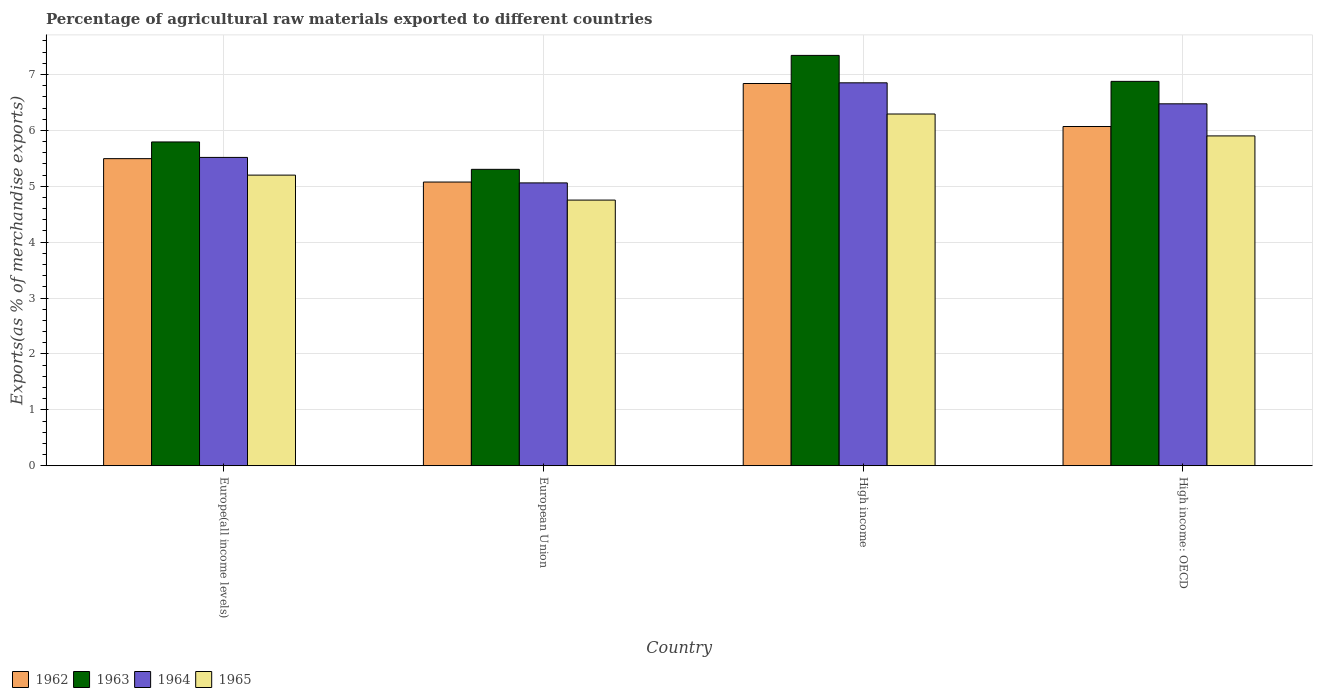How many bars are there on the 2nd tick from the left?
Offer a very short reply. 4. What is the percentage of exports to different countries in 1965 in High income?
Keep it short and to the point. 6.29. Across all countries, what is the maximum percentage of exports to different countries in 1965?
Keep it short and to the point. 6.29. Across all countries, what is the minimum percentage of exports to different countries in 1963?
Give a very brief answer. 5.3. What is the total percentage of exports to different countries in 1965 in the graph?
Your answer should be very brief. 22.14. What is the difference between the percentage of exports to different countries in 1963 in European Union and that in High income: OECD?
Keep it short and to the point. -1.57. What is the difference between the percentage of exports to different countries in 1963 in High income: OECD and the percentage of exports to different countries in 1964 in European Union?
Your answer should be compact. 1.82. What is the average percentage of exports to different countries in 1963 per country?
Your response must be concise. 6.33. What is the difference between the percentage of exports to different countries of/in 1962 and percentage of exports to different countries of/in 1963 in High income?
Offer a very short reply. -0.5. In how many countries, is the percentage of exports to different countries in 1964 greater than 0.2 %?
Offer a terse response. 4. What is the ratio of the percentage of exports to different countries in 1965 in Europe(all income levels) to that in European Union?
Offer a very short reply. 1.09. Is the difference between the percentage of exports to different countries in 1962 in Europe(all income levels) and High income greater than the difference between the percentage of exports to different countries in 1963 in Europe(all income levels) and High income?
Provide a succinct answer. Yes. What is the difference between the highest and the second highest percentage of exports to different countries in 1964?
Provide a succinct answer. -1.33. What is the difference between the highest and the lowest percentage of exports to different countries in 1963?
Offer a terse response. 2.04. Is the sum of the percentage of exports to different countries in 1962 in European Union and High income greater than the maximum percentage of exports to different countries in 1963 across all countries?
Offer a very short reply. Yes. Is it the case that in every country, the sum of the percentage of exports to different countries in 1964 and percentage of exports to different countries in 1962 is greater than the sum of percentage of exports to different countries in 1965 and percentage of exports to different countries in 1963?
Your answer should be very brief. No. What does the 1st bar from the left in Europe(all income levels) represents?
Provide a short and direct response. 1962. What does the 1st bar from the right in European Union represents?
Your answer should be compact. 1965. Is it the case that in every country, the sum of the percentage of exports to different countries in 1965 and percentage of exports to different countries in 1964 is greater than the percentage of exports to different countries in 1962?
Your answer should be very brief. Yes. What is the difference between two consecutive major ticks on the Y-axis?
Give a very brief answer. 1. Are the values on the major ticks of Y-axis written in scientific E-notation?
Offer a terse response. No. Does the graph contain grids?
Provide a succinct answer. Yes. How many legend labels are there?
Offer a terse response. 4. What is the title of the graph?
Make the answer very short. Percentage of agricultural raw materials exported to different countries. Does "1993" appear as one of the legend labels in the graph?
Give a very brief answer. No. What is the label or title of the X-axis?
Your answer should be compact. Country. What is the label or title of the Y-axis?
Give a very brief answer. Exports(as % of merchandise exports). What is the Exports(as % of merchandise exports) of 1962 in Europe(all income levels)?
Your answer should be very brief. 5.49. What is the Exports(as % of merchandise exports) in 1963 in Europe(all income levels)?
Your response must be concise. 5.79. What is the Exports(as % of merchandise exports) of 1964 in Europe(all income levels)?
Keep it short and to the point. 5.52. What is the Exports(as % of merchandise exports) of 1965 in Europe(all income levels)?
Your answer should be very brief. 5.2. What is the Exports(as % of merchandise exports) of 1962 in European Union?
Offer a very short reply. 5.08. What is the Exports(as % of merchandise exports) of 1963 in European Union?
Offer a very short reply. 5.3. What is the Exports(as % of merchandise exports) of 1964 in European Union?
Your answer should be compact. 5.06. What is the Exports(as % of merchandise exports) of 1965 in European Union?
Your answer should be compact. 4.75. What is the Exports(as % of merchandise exports) in 1962 in High income?
Your response must be concise. 6.84. What is the Exports(as % of merchandise exports) in 1963 in High income?
Provide a short and direct response. 7.34. What is the Exports(as % of merchandise exports) of 1964 in High income?
Provide a succinct answer. 6.85. What is the Exports(as % of merchandise exports) of 1965 in High income?
Provide a short and direct response. 6.29. What is the Exports(as % of merchandise exports) of 1962 in High income: OECD?
Make the answer very short. 6.07. What is the Exports(as % of merchandise exports) in 1963 in High income: OECD?
Your response must be concise. 6.88. What is the Exports(as % of merchandise exports) of 1964 in High income: OECD?
Make the answer very short. 6.47. What is the Exports(as % of merchandise exports) in 1965 in High income: OECD?
Your response must be concise. 5.9. Across all countries, what is the maximum Exports(as % of merchandise exports) in 1962?
Ensure brevity in your answer.  6.84. Across all countries, what is the maximum Exports(as % of merchandise exports) in 1963?
Your answer should be compact. 7.34. Across all countries, what is the maximum Exports(as % of merchandise exports) in 1964?
Your answer should be very brief. 6.85. Across all countries, what is the maximum Exports(as % of merchandise exports) in 1965?
Make the answer very short. 6.29. Across all countries, what is the minimum Exports(as % of merchandise exports) of 1962?
Make the answer very short. 5.08. Across all countries, what is the minimum Exports(as % of merchandise exports) in 1963?
Make the answer very short. 5.3. Across all countries, what is the minimum Exports(as % of merchandise exports) in 1964?
Your response must be concise. 5.06. Across all countries, what is the minimum Exports(as % of merchandise exports) of 1965?
Your response must be concise. 4.75. What is the total Exports(as % of merchandise exports) in 1962 in the graph?
Give a very brief answer. 23.48. What is the total Exports(as % of merchandise exports) of 1963 in the graph?
Ensure brevity in your answer.  25.31. What is the total Exports(as % of merchandise exports) of 1964 in the graph?
Offer a very short reply. 23.9. What is the total Exports(as % of merchandise exports) in 1965 in the graph?
Your response must be concise. 22.14. What is the difference between the Exports(as % of merchandise exports) of 1962 in Europe(all income levels) and that in European Union?
Offer a very short reply. 0.42. What is the difference between the Exports(as % of merchandise exports) in 1963 in Europe(all income levels) and that in European Union?
Your answer should be compact. 0.49. What is the difference between the Exports(as % of merchandise exports) in 1964 in Europe(all income levels) and that in European Union?
Give a very brief answer. 0.46. What is the difference between the Exports(as % of merchandise exports) of 1965 in Europe(all income levels) and that in European Union?
Give a very brief answer. 0.45. What is the difference between the Exports(as % of merchandise exports) of 1962 in Europe(all income levels) and that in High income?
Ensure brevity in your answer.  -1.34. What is the difference between the Exports(as % of merchandise exports) of 1963 in Europe(all income levels) and that in High income?
Keep it short and to the point. -1.55. What is the difference between the Exports(as % of merchandise exports) of 1964 in Europe(all income levels) and that in High income?
Give a very brief answer. -1.33. What is the difference between the Exports(as % of merchandise exports) of 1965 in Europe(all income levels) and that in High income?
Give a very brief answer. -1.09. What is the difference between the Exports(as % of merchandise exports) of 1962 in Europe(all income levels) and that in High income: OECD?
Provide a succinct answer. -0.57. What is the difference between the Exports(as % of merchandise exports) of 1963 in Europe(all income levels) and that in High income: OECD?
Your response must be concise. -1.08. What is the difference between the Exports(as % of merchandise exports) of 1964 in Europe(all income levels) and that in High income: OECD?
Offer a very short reply. -0.96. What is the difference between the Exports(as % of merchandise exports) of 1965 in Europe(all income levels) and that in High income: OECD?
Keep it short and to the point. -0.7. What is the difference between the Exports(as % of merchandise exports) of 1962 in European Union and that in High income?
Keep it short and to the point. -1.76. What is the difference between the Exports(as % of merchandise exports) of 1963 in European Union and that in High income?
Keep it short and to the point. -2.04. What is the difference between the Exports(as % of merchandise exports) of 1964 in European Union and that in High income?
Give a very brief answer. -1.79. What is the difference between the Exports(as % of merchandise exports) of 1965 in European Union and that in High income?
Your answer should be compact. -1.54. What is the difference between the Exports(as % of merchandise exports) in 1962 in European Union and that in High income: OECD?
Ensure brevity in your answer.  -0.99. What is the difference between the Exports(as % of merchandise exports) of 1963 in European Union and that in High income: OECD?
Offer a very short reply. -1.57. What is the difference between the Exports(as % of merchandise exports) of 1964 in European Union and that in High income: OECD?
Give a very brief answer. -1.41. What is the difference between the Exports(as % of merchandise exports) in 1965 in European Union and that in High income: OECD?
Your answer should be very brief. -1.15. What is the difference between the Exports(as % of merchandise exports) in 1962 in High income and that in High income: OECD?
Provide a short and direct response. 0.77. What is the difference between the Exports(as % of merchandise exports) in 1963 in High income and that in High income: OECD?
Give a very brief answer. 0.46. What is the difference between the Exports(as % of merchandise exports) of 1964 in High income and that in High income: OECD?
Give a very brief answer. 0.38. What is the difference between the Exports(as % of merchandise exports) in 1965 in High income and that in High income: OECD?
Your answer should be compact. 0.39. What is the difference between the Exports(as % of merchandise exports) of 1962 in Europe(all income levels) and the Exports(as % of merchandise exports) of 1963 in European Union?
Offer a terse response. 0.19. What is the difference between the Exports(as % of merchandise exports) in 1962 in Europe(all income levels) and the Exports(as % of merchandise exports) in 1964 in European Union?
Your answer should be very brief. 0.43. What is the difference between the Exports(as % of merchandise exports) in 1962 in Europe(all income levels) and the Exports(as % of merchandise exports) in 1965 in European Union?
Provide a short and direct response. 0.74. What is the difference between the Exports(as % of merchandise exports) in 1963 in Europe(all income levels) and the Exports(as % of merchandise exports) in 1964 in European Union?
Ensure brevity in your answer.  0.73. What is the difference between the Exports(as % of merchandise exports) in 1963 in Europe(all income levels) and the Exports(as % of merchandise exports) in 1965 in European Union?
Your answer should be compact. 1.04. What is the difference between the Exports(as % of merchandise exports) of 1964 in Europe(all income levels) and the Exports(as % of merchandise exports) of 1965 in European Union?
Give a very brief answer. 0.76. What is the difference between the Exports(as % of merchandise exports) of 1962 in Europe(all income levels) and the Exports(as % of merchandise exports) of 1963 in High income?
Ensure brevity in your answer.  -1.85. What is the difference between the Exports(as % of merchandise exports) in 1962 in Europe(all income levels) and the Exports(as % of merchandise exports) in 1964 in High income?
Ensure brevity in your answer.  -1.36. What is the difference between the Exports(as % of merchandise exports) of 1962 in Europe(all income levels) and the Exports(as % of merchandise exports) of 1965 in High income?
Provide a short and direct response. -0.8. What is the difference between the Exports(as % of merchandise exports) of 1963 in Europe(all income levels) and the Exports(as % of merchandise exports) of 1964 in High income?
Provide a short and direct response. -1.06. What is the difference between the Exports(as % of merchandise exports) of 1964 in Europe(all income levels) and the Exports(as % of merchandise exports) of 1965 in High income?
Your answer should be compact. -0.78. What is the difference between the Exports(as % of merchandise exports) in 1962 in Europe(all income levels) and the Exports(as % of merchandise exports) in 1963 in High income: OECD?
Your answer should be compact. -1.38. What is the difference between the Exports(as % of merchandise exports) of 1962 in Europe(all income levels) and the Exports(as % of merchandise exports) of 1964 in High income: OECD?
Your answer should be very brief. -0.98. What is the difference between the Exports(as % of merchandise exports) of 1962 in Europe(all income levels) and the Exports(as % of merchandise exports) of 1965 in High income: OECD?
Give a very brief answer. -0.41. What is the difference between the Exports(as % of merchandise exports) of 1963 in Europe(all income levels) and the Exports(as % of merchandise exports) of 1964 in High income: OECD?
Make the answer very short. -0.68. What is the difference between the Exports(as % of merchandise exports) in 1963 in Europe(all income levels) and the Exports(as % of merchandise exports) in 1965 in High income: OECD?
Keep it short and to the point. -0.11. What is the difference between the Exports(as % of merchandise exports) in 1964 in Europe(all income levels) and the Exports(as % of merchandise exports) in 1965 in High income: OECD?
Keep it short and to the point. -0.38. What is the difference between the Exports(as % of merchandise exports) of 1962 in European Union and the Exports(as % of merchandise exports) of 1963 in High income?
Your response must be concise. -2.27. What is the difference between the Exports(as % of merchandise exports) of 1962 in European Union and the Exports(as % of merchandise exports) of 1964 in High income?
Your answer should be compact. -1.78. What is the difference between the Exports(as % of merchandise exports) of 1962 in European Union and the Exports(as % of merchandise exports) of 1965 in High income?
Give a very brief answer. -1.22. What is the difference between the Exports(as % of merchandise exports) in 1963 in European Union and the Exports(as % of merchandise exports) in 1964 in High income?
Your answer should be compact. -1.55. What is the difference between the Exports(as % of merchandise exports) of 1963 in European Union and the Exports(as % of merchandise exports) of 1965 in High income?
Make the answer very short. -0.99. What is the difference between the Exports(as % of merchandise exports) in 1964 in European Union and the Exports(as % of merchandise exports) in 1965 in High income?
Your answer should be compact. -1.23. What is the difference between the Exports(as % of merchandise exports) of 1962 in European Union and the Exports(as % of merchandise exports) of 1963 in High income: OECD?
Ensure brevity in your answer.  -1.8. What is the difference between the Exports(as % of merchandise exports) in 1962 in European Union and the Exports(as % of merchandise exports) in 1964 in High income: OECD?
Give a very brief answer. -1.4. What is the difference between the Exports(as % of merchandise exports) of 1962 in European Union and the Exports(as % of merchandise exports) of 1965 in High income: OECD?
Keep it short and to the point. -0.83. What is the difference between the Exports(as % of merchandise exports) in 1963 in European Union and the Exports(as % of merchandise exports) in 1964 in High income: OECD?
Your answer should be very brief. -1.17. What is the difference between the Exports(as % of merchandise exports) of 1963 in European Union and the Exports(as % of merchandise exports) of 1965 in High income: OECD?
Offer a very short reply. -0.6. What is the difference between the Exports(as % of merchandise exports) in 1964 in European Union and the Exports(as % of merchandise exports) in 1965 in High income: OECD?
Make the answer very short. -0.84. What is the difference between the Exports(as % of merchandise exports) in 1962 in High income and the Exports(as % of merchandise exports) in 1963 in High income: OECD?
Your response must be concise. -0.04. What is the difference between the Exports(as % of merchandise exports) in 1962 in High income and the Exports(as % of merchandise exports) in 1964 in High income: OECD?
Give a very brief answer. 0.36. What is the difference between the Exports(as % of merchandise exports) of 1962 in High income and the Exports(as % of merchandise exports) of 1965 in High income: OECD?
Your response must be concise. 0.94. What is the difference between the Exports(as % of merchandise exports) in 1963 in High income and the Exports(as % of merchandise exports) in 1964 in High income: OECD?
Provide a succinct answer. 0.87. What is the difference between the Exports(as % of merchandise exports) in 1963 in High income and the Exports(as % of merchandise exports) in 1965 in High income: OECD?
Your answer should be very brief. 1.44. What is the average Exports(as % of merchandise exports) in 1962 per country?
Your answer should be very brief. 5.87. What is the average Exports(as % of merchandise exports) of 1963 per country?
Make the answer very short. 6.33. What is the average Exports(as % of merchandise exports) in 1964 per country?
Provide a short and direct response. 5.98. What is the average Exports(as % of merchandise exports) in 1965 per country?
Keep it short and to the point. 5.54. What is the difference between the Exports(as % of merchandise exports) in 1962 and Exports(as % of merchandise exports) in 1963 in Europe(all income levels)?
Provide a short and direct response. -0.3. What is the difference between the Exports(as % of merchandise exports) in 1962 and Exports(as % of merchandise exports) in 1964 in Europe(all income levels)?
Offer a very short reply. -0.02. What is the difference between the Exports(as % of merchandise exports) of 1962 and Exports(as % of merchandise exports) of 1965 in Europe(all income levels)?
Ensure brevity in your answer.  0.29. What is the difference between the Exports(as % of merchandise exports) of 1963 and Exports(as % of merchandise exports) of 1964 in Europe(all income levels)?
Your response must be concise. 0.28. What is the difference between the Exports(as % of merchandise exports) in 1963 and Exports(as % of merchandise exports) in 1965 in Europe(all income levels)?
Your answer should be very brief. 0.59. What is the difference between the Exports(as % of merchandise exports) of 1964 and Exports(as % of merchandise exports) of 1965 in Europe(all income levels)?
Offer a terse response. 0.32. What is the difference between the Exports(as % of merchandise exports) in 1962 and Exports(as % of merchandise exports) in 1963 in European Union?
Your answer should be very brief. -0.23. What is the difference between the Exports(as % of merchandise exports) of 1962 and Exports(as % of merchandise exports) of 1964 in European Union?
Keep it short and to the point. 0.02. What is the difference between the Exports(as % of merchandise exports) in 1962 and Exports(as % of merchandise exports) in 1965 in European Union?
Your answer should be compact. 0.32. What is the difference between the Exports(as % of merchandise exports) of 1963 and Exports(as % of merchandise exports) of 1964 in European Union?
Your response must be concise. 0.24. What is the difference between the Exports(as % of merchandise exports) in 1963 and Exports(as % of merchandise exports) in 1965 in European Union?
Give a very brief answer. 0.55. What is the difference between the Exports(as % of merchandise exports) of 1964 and Exports(as % of merchandise exports) of 1965 in European Union?
Make the answer very short. 0.31. What is the difference between the Exports(as % of merchandise exports) in 1962 and Exports(as % of merchandise exports) in 1963 in High income?
Provide a succinct answer. -0.5. What is the difference between the Exports(as % of merchandise exports) in 1962 and Exports(as % of merchandise exports) in 1964 in High income?
Provide a short and direct response. -0.01. What is the difference between the Exports(as % of merchandise exports) of 1962 and Exports(as % of merchandise exports) of 1965 in High income?
Your answer should be compact. 0.55. What is the difference between the Exports(as % of merchandise exports) in 1963 and Exports(as % of merchandise exports) in 1964 in High income?
Keep it short and to the point. 0.49. What is the difference between the Exports(as % of merchandise exports) in 1963 and Exports(as % of merchandise exports) in 1965 in High income?
Make the answer very short. 1.05. What is the difference between the Exports(as % of merchandise exports) of 1964 and Exports(as % of merchandise exports) of 1965 in High income?
Your answer should be compact. 0.56. What is the difference between the Exports(as % of merchandise exports) of 1962 and Exports(as % of merchandise exports) of 1963 in High income: OECD?
Your answer should be compact. -0.81. What is the difference between the Exports(as % of merchandise exports) in 1962 and Exports(as % of merchandise exports) in 1964 in High income: OECD?
Give a very brief answer. -0.41. What is the difference between the Exports(as % of merchandise exports) of 1962 and Exports(as % of merchandise exports) of 1965 in High income: OECD?
Your answer should be compact. 0.17. What is the difference between the Exports(as % of merchandise exports) of 1963 and Exports(as % of merchandise exports) of 1964 in High income: OECD?
Keep it short and to the point. 0.4. What is the difference between the Exports(as % of merchandise exports) of 1963 and Exports(as % of merchandise exports) of 1965 in High income: OECD?
Provide a short and direct response. 0.98. What is the difference between the Exports(as % of merchandise exports) in 1964 and Exports(as % of merchandise exports) in 1965 in High income: OECD?
Provide a succinct answer. 0.57. What is the ratio of the Exports(as % of merchandise exports) in 1962 in Europe(all income levels) to that in European Union?
Make the answer very short. 1.08. What is the ratio of the Exports(as % of merchandise exports) in 1963 in Europe(all income levels) to that in European Union?
Your response must be concise. 1.09. What is the ratio of the Exports(as % of merchandise exports) in 1964 in Europe(all income levels) to that in European Union?
Ensure brevity in your answer.  1.09. What is the ratio of the Exports(as % of merchandise exports) in 1965 in Europe(all income levels) to that in European Union?
Keep it short and to the point. 1.09. What is the ratio of the Exports(as % of merchandise exports) of 1962 in Europe(all income levels) to that in High income?
Provide a short and direct response. 0.8. What is the ratio of the Exports(as % of merchandise exports) of 1963 in Europe(all income levels) to that in High income?
Your response must be concise. 0.79. What is the ratio of the Exports(as % of merchandise exports) in 1964 in Europe(all income levels) to that in High income?
Provide a short and direct response. 0.81. What is the ratio of the Exports(as % of merchandise exports) of 1965 in Europe(all income levels) to that in High income?
Keep it short and to the point. 0.83. What is the ratio of the Exports(as % of merchandise exports) in 1962 in Europe(all income levels) to that in High income: OECD?
Provide a succinct answer. 0.91. What is the ratio of the Exports(as % of merchandise exports) of 1963 in Europe(all income levels) to that in High income: OECD?
Keep it short and to the point. 0.84. What is the ratio of the Exports(as % of merchandise exports) of 1964 in Europe(all income levels) to that in High income: OECD?
Provide a succinct answer. 0.85. What is the ratio of the Exports(as % of merchandise exports) of 1965 in Europe(all income levels) to that in High income: OECD?
Give a very brief answer. 0.88. What is the ratio of the Exports(as % of merchandise exports) in 1962 in European Union to that in High income?
Provide a succinct answer. 0.74. What is the ratio of the Exports(as % of merchandise exports) of 1963 in European Union to that in High income?
Your answer should be compact. 0.72. What is the ratio of the Exports(as % of merchandise exports) of 1964 in European Union to that in High income?
Your answer should be compact. 0.74. What is the ratio of the Exports(as % of merchandise exports) of 1965 in European Union to that in High income?
Provide a short and direct response. 0.76. What is the ratio of the Exports(as % of merchandise exports) in 1962 in European Union to that in High income: OECD?
Your answer should be compact. 0.84. What is the ratio of the Exports(as % of merchandise exports) in 1963 in European Union to that in High income: OECD?
Make the answer very short. 0.77. What is the ratio of the Exports(as % of merchandise exports) in 1964 in European Union to that in High income: OECD?
Your response must be concise. 0.78. What is the ratio of the Exports(as % of merchandise exports) in 1965 in European Union to that in High income: OECD?
Give a very brief answer. 0.81. What is the ratio of the Exports(as % of merchandise exports) in 1962 in High income to that in High income: OECD?
Provide a succinct answer. 1.13. What is the ratio of the Exports(as % of merchandise exports) in 1963 in High income to that in High income: OECD?
Offer a terse response. 1.07. What is the ratio of the Exports(as % of merchandise exports) in 1964 in High income to that in High income: OECD?
Provide a short and direct response. 1.06. What is the ratio of the Exports(as % of merchandise exports) of 1965 in High income to that in High income: OECD?
Ensure brevity in your answer.  1.07. What is the difference between the highest and the second highest Exports(as % of merchandise exports) of 1962?
Provide a short and direct response. 0.77. What is the difference between the highest and the second highest Exports(as % of merchandise exports) of 1963?
Your answer should be very brief. 0.46. What is the difference between the highest and the second highest Exports(as % of merchandise exports) of 1964?
Offer a very short reply. 0.38. What is the difference between the highest and the second highest Exports(as % of merchandise exports) of 1965?
Give a very brief answer. 0.39. What is the difference between the highest and the lowest Exports(as % of merchandise exports) of 1962?
Your answer should be compact. 1.76. What is the difference between the highest and the lowest Exports(as % of merchandise exports) in 1963?
Offer a very short reply. 2.04. What is the difference between the highest and the lowest Exports(as % of merchandise exports) in 1964?
Your answer should be compact. 1.79. What is the difference between the highest and the lowest Exports(as % of merchandise exports) of 1965?
Offer a terse response. 1.54. 